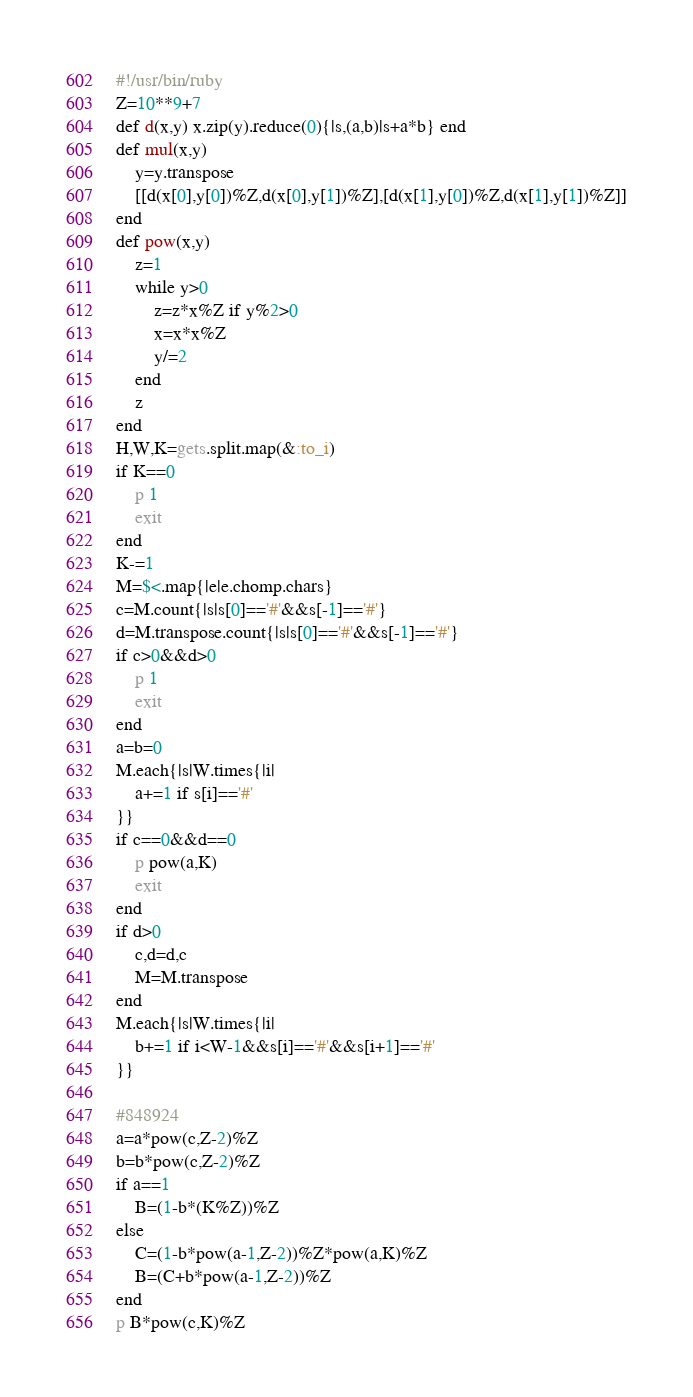<code> <loc_0><loc_0><loc_500><loc_500><_Ruby_>#!/usr/bin/ruby
Z=10**9+7
def d(x,y) x.zip(y).reduce(0){|s,(a,b)|s+a*b} end
def mul(x,y)
	y=y.transpose
	[[d(x[0],y[0])%Z,d(x[0],y[1])%Z],[d(x[1],y[0])%Z,d(x[1],y[1])%Z]]
end
def pow(x,y)
	z=1
	while y>0
		z=z*x%Z if y%2>0
		x=x*x%Z
		y/=2
	end
	z
end
H,W,K=gets.split.map(&:to_i)
if K==0
	p 1
	exit
end
K-=1
M=$<.map{|e|e.chomp.chars}
c=M.count{|s|s[0]=='#'&&s[-1]=='#'}
d=M.transpose.count{|s|s[0]=='#'&&s[-1]=='#'}
if c>0&&d>0
	p 1
	exit
end
a=b=0
M.each{|s|W.times{|i|
	a+=1 if s[i]=='#'
}}
if c==0&&d==0
	p pow(a,K)
	exit
end
if d>0
	c,d=d,c
	M=M.transpose
end
M.each{|s|W.times{|i|
	b+=1 if i<W-1&&s[i]=='#'&&s[i+1]=='#'
}}

#848924
a=a*pow(c,Z-2)%Z
b=b*pow(c,Z-2)%Z
if a==1
	B=(1-b*(K%Z))%Z
else
	C=(1-b*pow(a-1,Z-2))%Z*pow(a,K)%Z
	B=(C+b*pow(a-1,Z-2))%Z
end
p B*pow(c,K)%Z</code> 